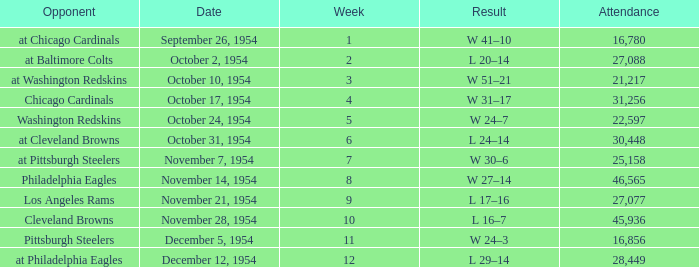How many weeks have october 31, 1954 as the date? 1.0. 